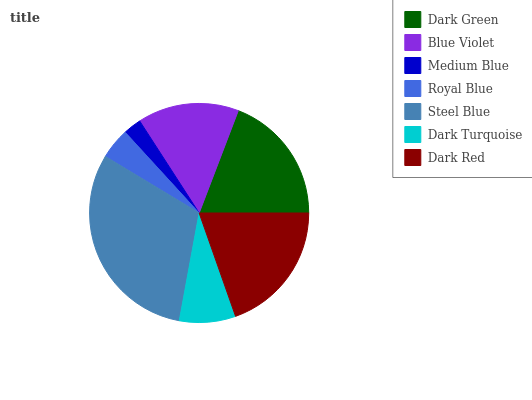Is Medium Blue the minimum?
Answer yes or no. Yes. Is Steel Blue the maximum?
Answer yes or no. Yes. Is Blue Violet the minimum?
Answer yes or no. No. Is Blue Violet the maximum?
Answer yes or no. No. Is Dark Green greater than Blue Violet?
Answer yes or no. Yes. Is Blue Violet less than Dark Green?
Answer yes or no. Yes. Is Blue Violet greater than Dark Green?
Answer yes or no. No. Is Dark Green less than Blue Violet?
Answer yes or no. No. Is Blue Violet the high median?
Answer yes or no. Yes. Is Blue Violet the low median?
Answer yes or no. Yes. Is Dark Green the high median?
Answer yes or no. No. Is Royal Blue the low median?
Answer yes or no. No. 